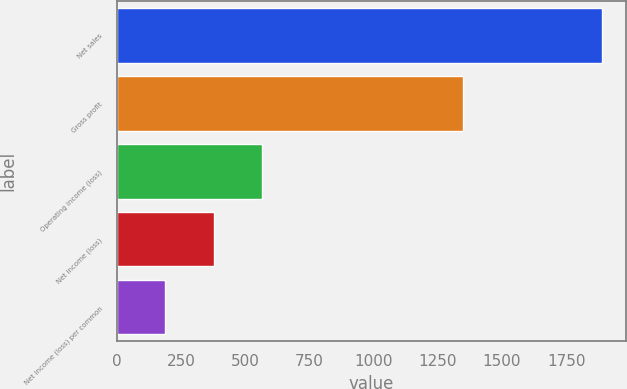Convert chart to OTSL. <chart><loc_0><loc_0><loc_500><loc_500><bar_chart><fcel>Net sales<fcel>Gross profit<fcel>Operating income (loss)<fcel>Net income (loss)<fcel>Net income (loss) per common<nl><fcel>1888<fcel>1349<fcel>566.51<fcel>377.73<fcel>188.94<nl></chart> 